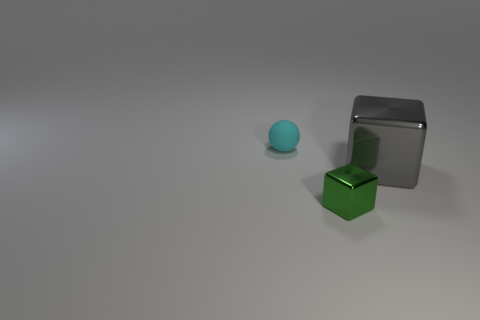How many objects are tiny objects or blue matte spheres? 2 